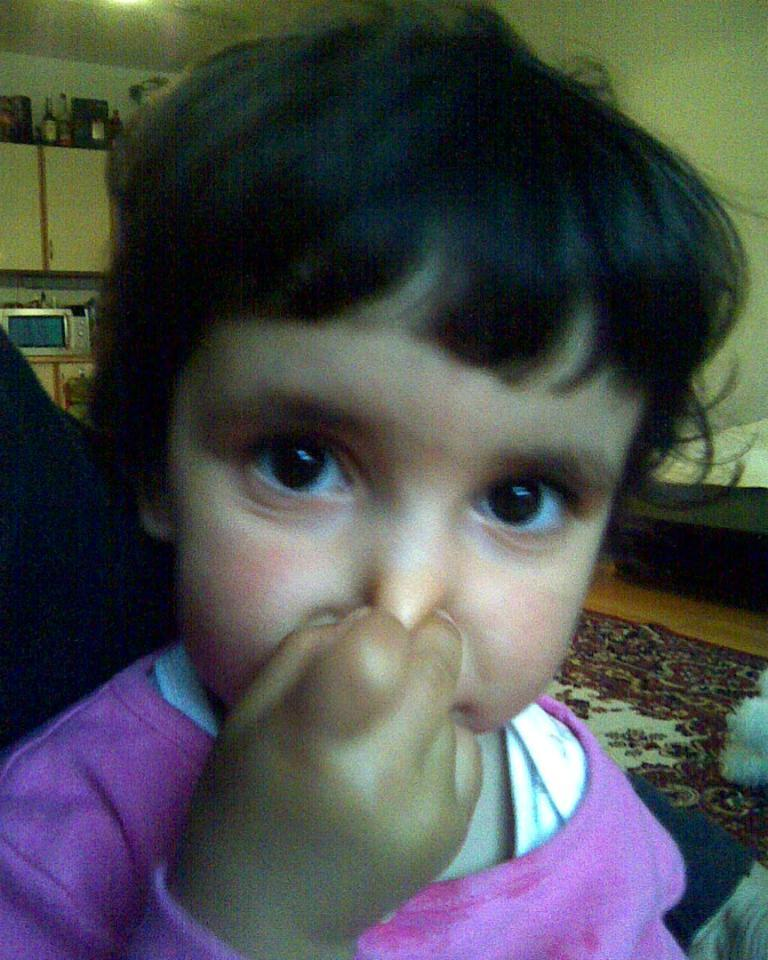What is the main subject in the foreground of the image? There is a child in the foreground of the image. What is the child doing in the image? The child is pressing their nose. Can you describe the child's appearance? The child has black hair. What type of lamp is visible on the child's face in the image? There is no lamp visible on the child's face in the image. What kind of pickle is the child holding in the image? There is no pickle present in the image. 